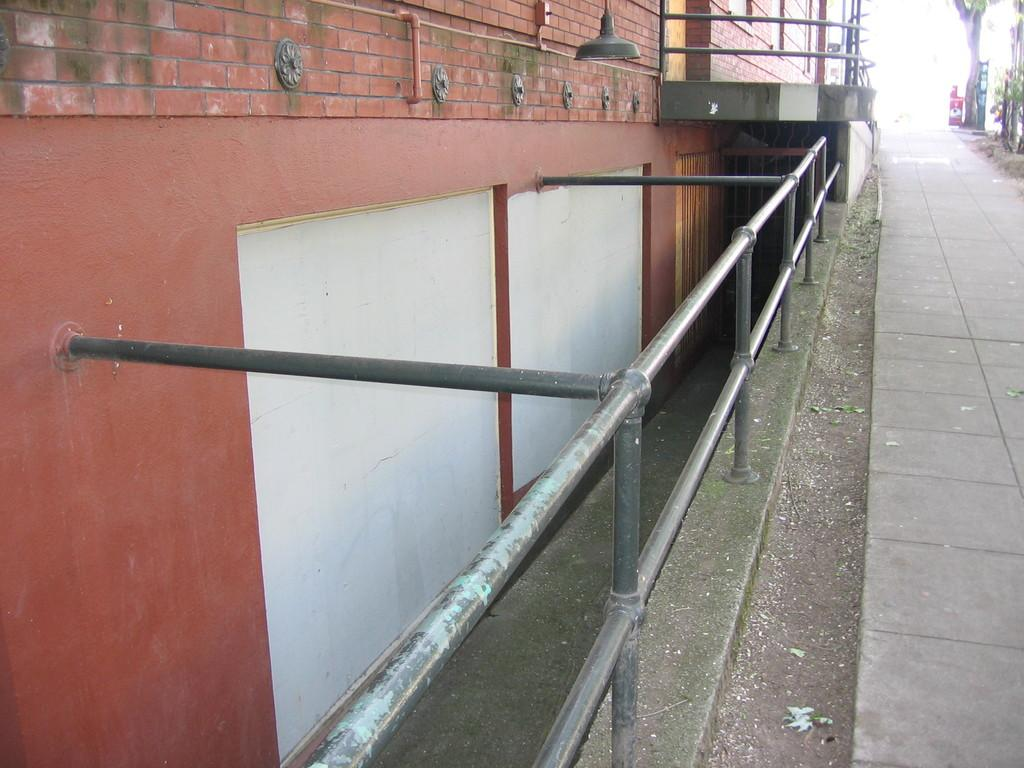What type of fence is visible in the image? There is a pole fence in the image. How is the pole fence connected to the building? The pole fence is attached to a building. What is the color of the building in the image? The building is in brick color. What type of tank is visible in the image? There is no tank present in the image; it only features a pole fence and a brick-colored building. 